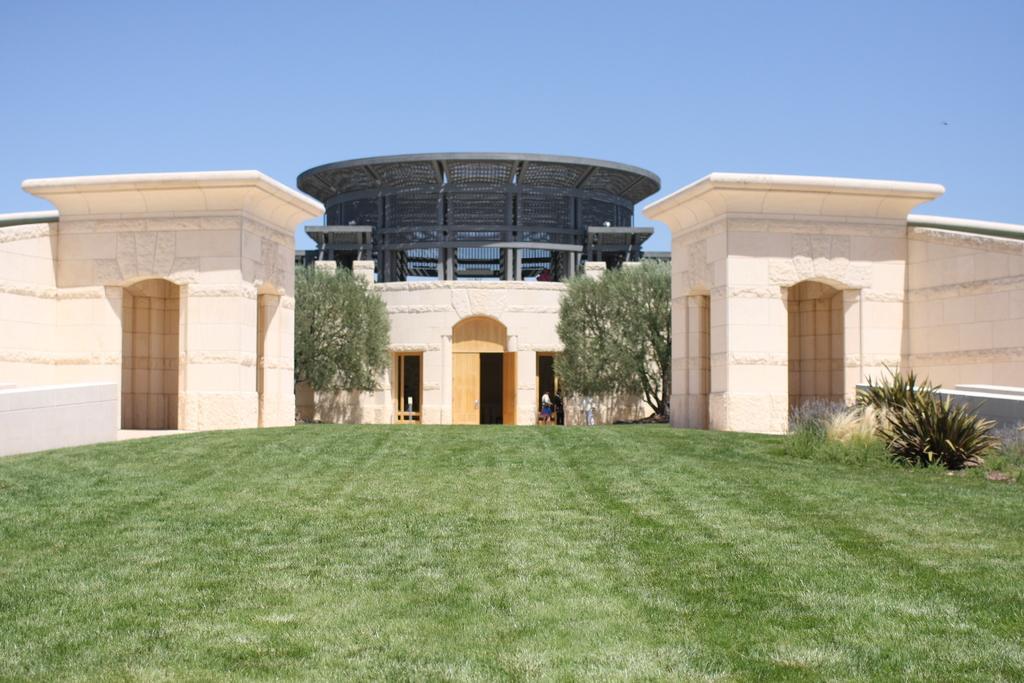How would you summarize this image in a sentence or two? There is grass on the ground. In the background, there are plants, trees, buildings, and architecture and there is blue sky. 